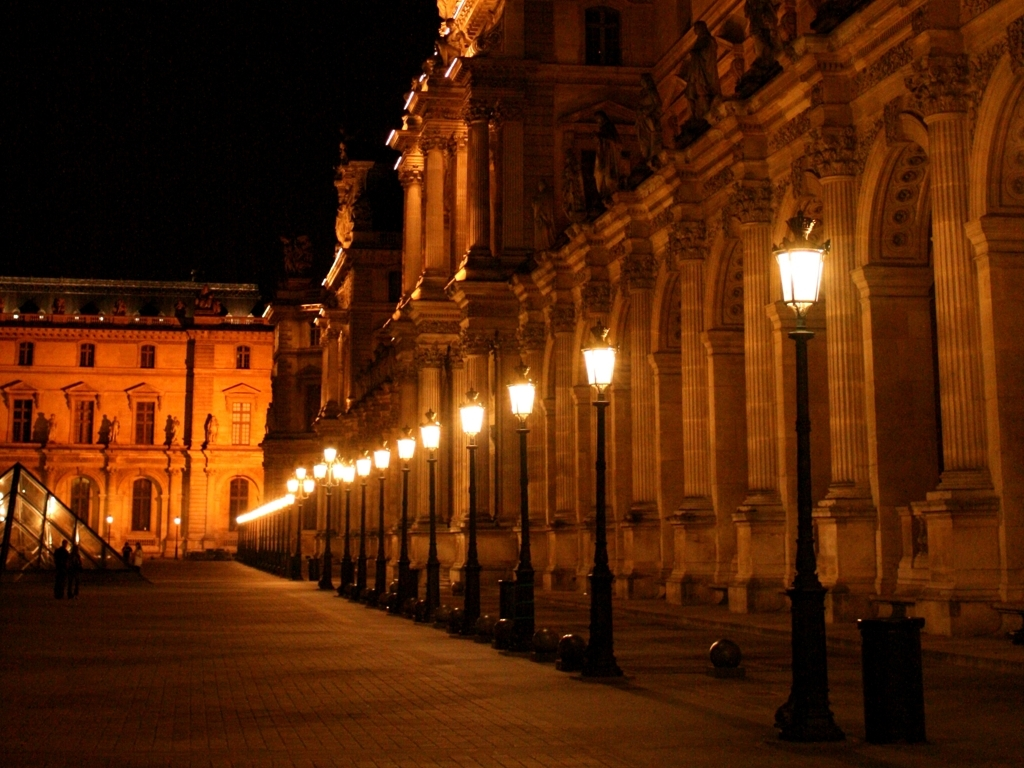What might be the purpose of this building? The structure in the image appears to be a historical or cultural building, possibly a museum or art gallery, given its classical architectural elements and stately presence. 